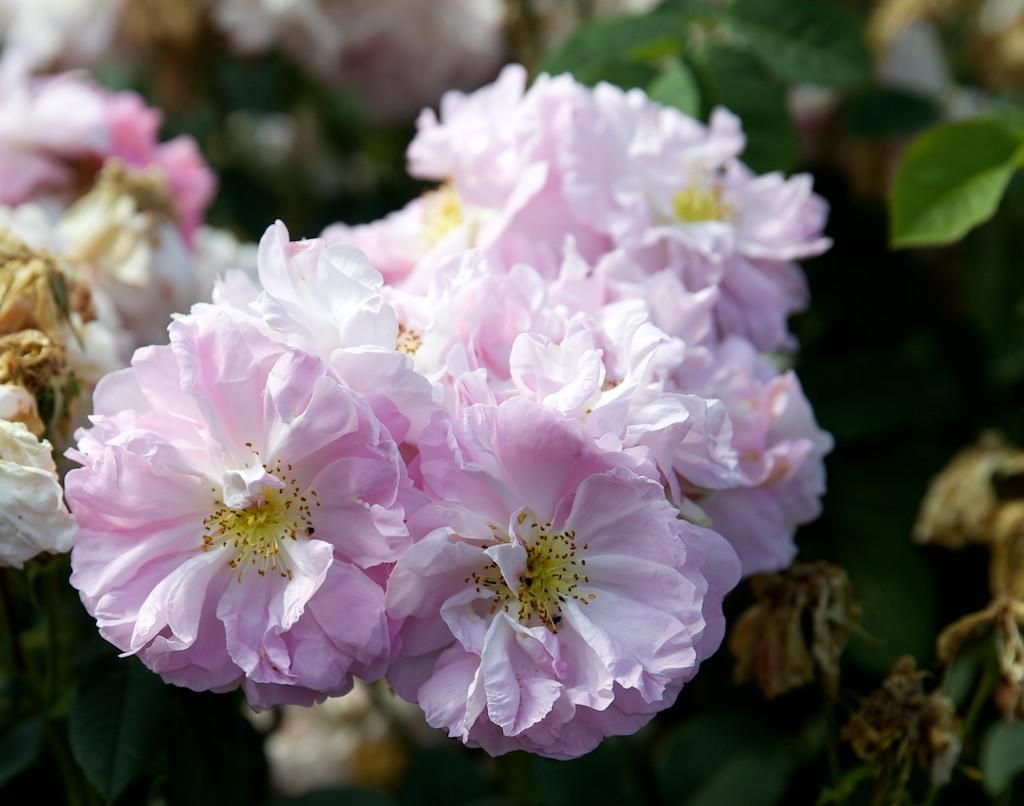In one or two sentences, can you explain what this image depicts? As we can see in the image there are plants and pink color flowers. 